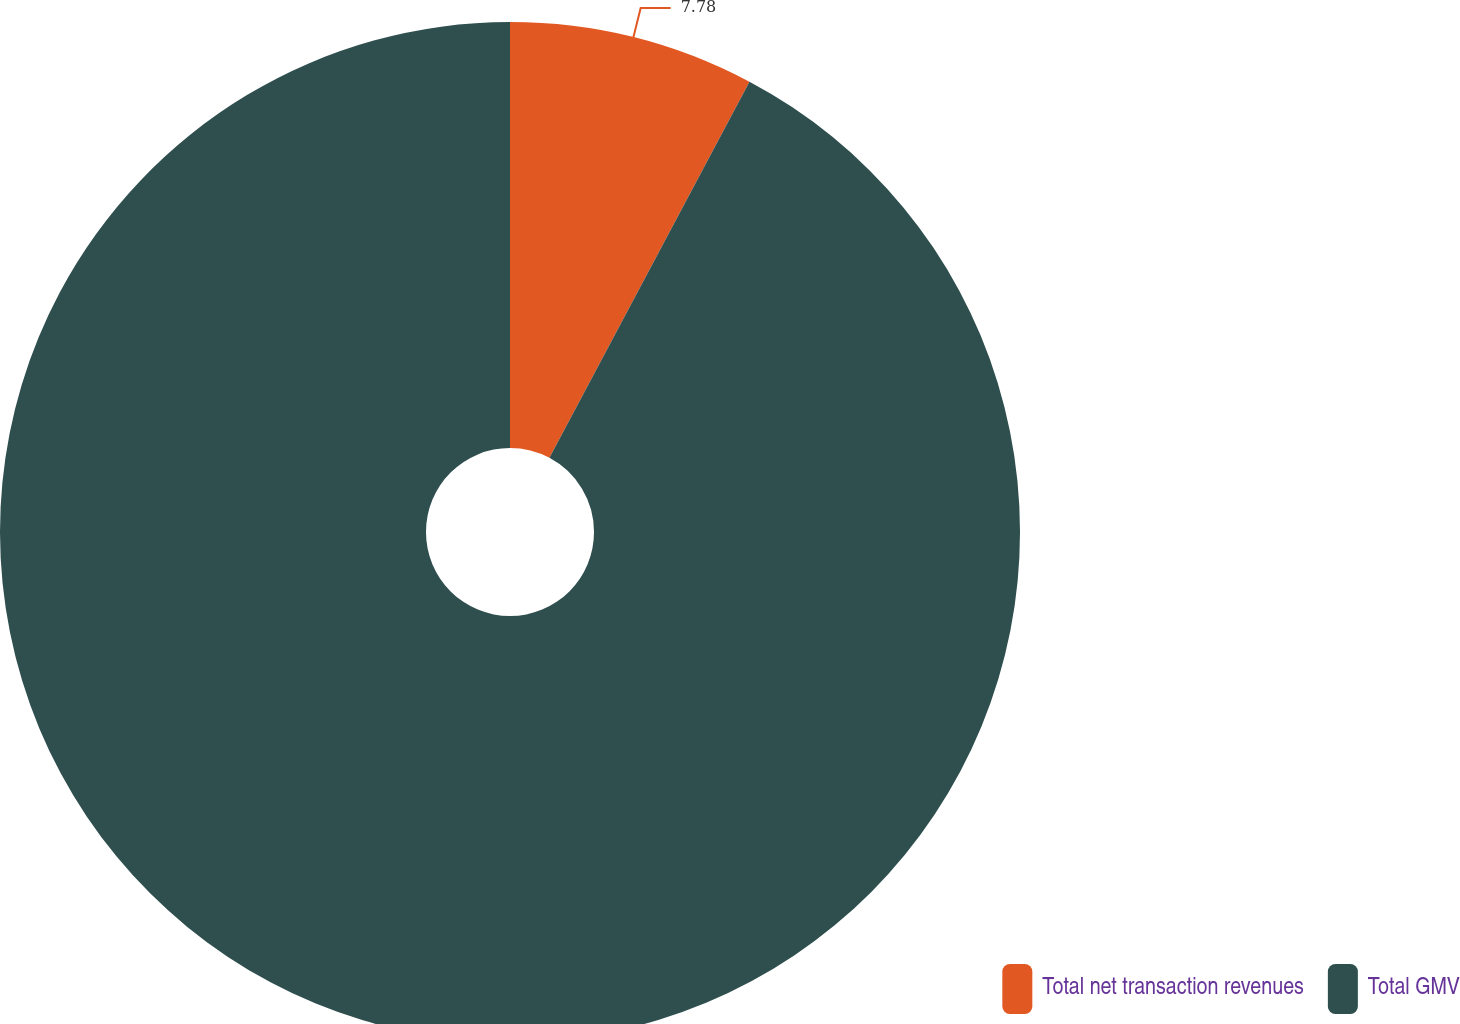Convert chart. <chart><loc_0><loc_0><loc_500><loc_500><pie_chart><fcel>Total net transaction revenues<fcel>Total GMV<nl><fcel>7.78%<fcel>92.22%<nl></chart> 